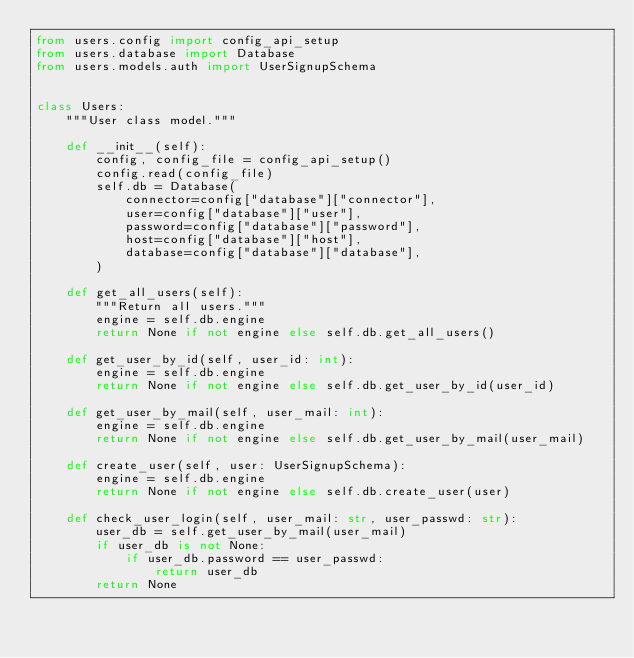Convert code to text. <code><loc_0><loc_0><loc_500><loc_500><_Python_>from users.config import config_api_setup
from users.database import Database
from users.models.auth import UserSignupSchema


class Users:
    """User class model."""

    def __init__(self):
        config, config_file = config_api_setup()
        config.read(config_file)
        self.db = Database(
            connector=config["database"]["connector"],
            user=config["database"]["user"],
            password=config["database"]["password"],
            host=config["database"]["host"],
            database=config["database"]["database"],
        )

    def get_all_users(self):
        """Return all users."""
        engine = self.db.engine
        return None if not engine else self.db.get_all_users()

    def get_user_by_id(self, user_id: int):
        engine = self.db.engine
        return None if not engine else self.db.get_user_by_id(user_id)

    def get_user_by_mail(self, user_mail: int):
        engine = self.db.engine
        return None if not engine else self.db.get_user_by_mail(user_mail)

    def create_user(self, user: UserSignupSchema):
        engine = self.db.engine
        return None if not engine else self.db.create_user(user)

    def check_user_login(self, user_mail: str, user_passwd: str):
        user_db = self.get_user_by_mail(user_mail)
        if user_db is not None:
            if user_db.password == user_passwd:
                return user_db
        return None
</code> 